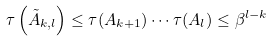<formula> <loc_0><loc_0><loc_500><loc_500>\tau \left ( \tilde { A } _ { k , l } \right ) \leq \tau ( A _ { k + 1 } ) \cdots \tau ( A _ { l } ) \leq \beta ^ { l - k }</formula> 